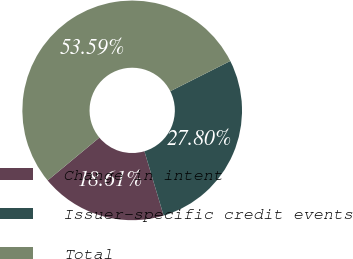Convert chart to OTSL. <chart><loc_0><loc_0><loc_500><loc_500><pie_chart><fcel>Change in intent<fcel>Issuer-specific credit events<fcel>Total<nl><fcel>18.61%<fcel>27.8%<fcel>53.59%<nl></chart> 